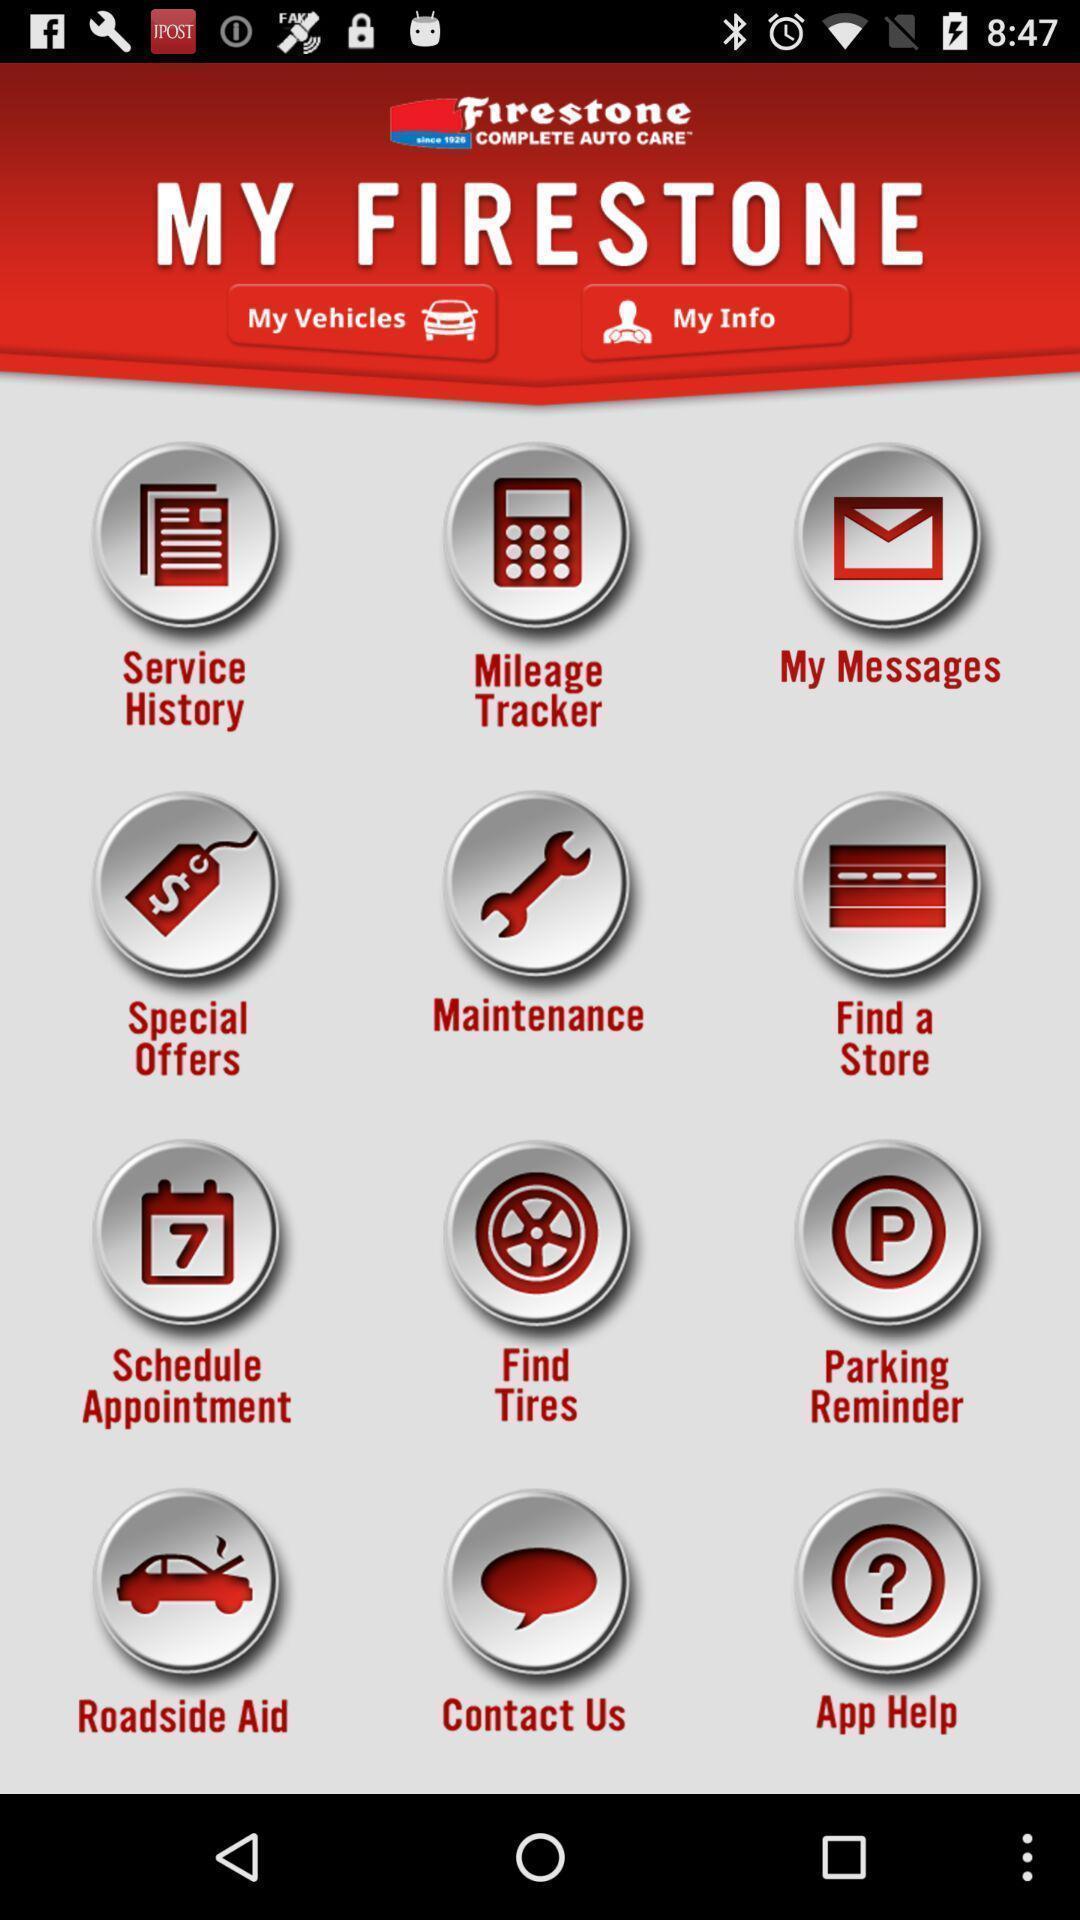Provide a textual representation of this image. Social app showing list of services. 